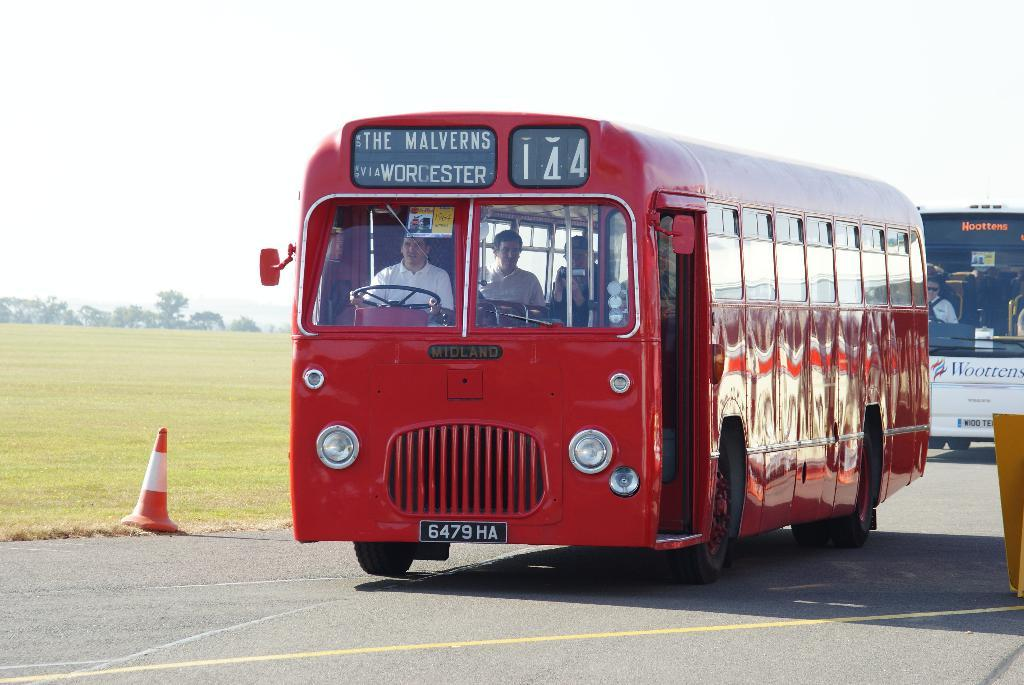<image>
Offer a succinct explanation of the picture presented. A red bus is headed to The Malverns after stopping in Worcester. 